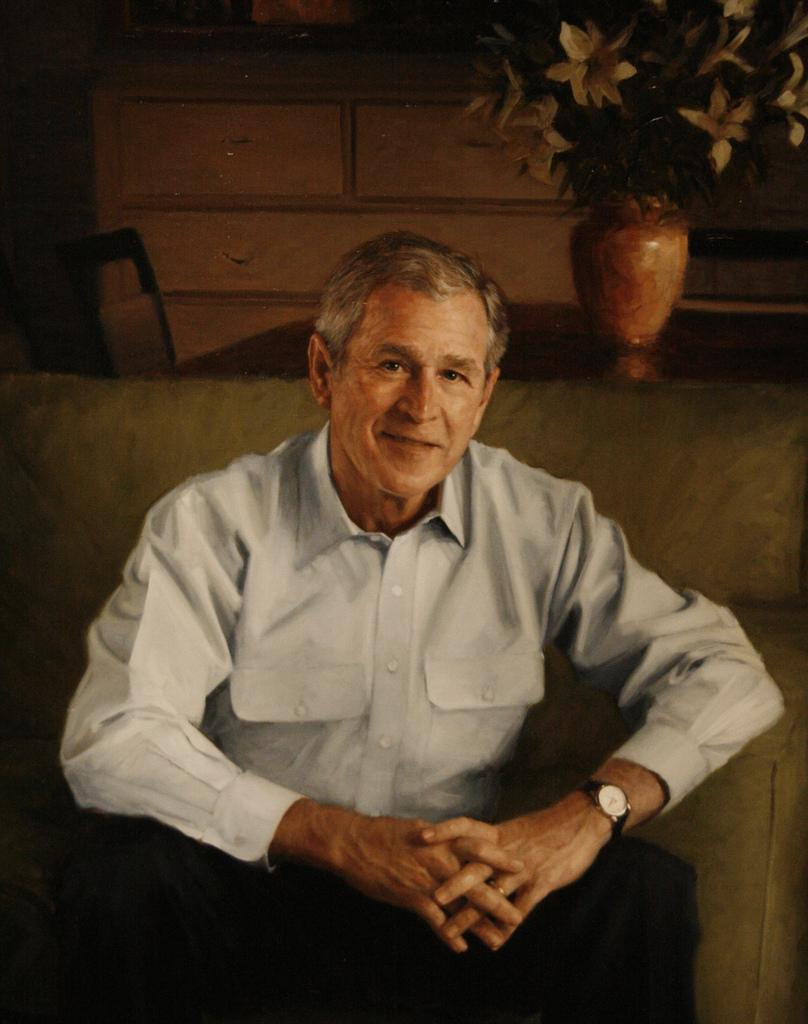What is the main subject of the image? There is a person sitting in the image. Can you describe the background of the image? There is a flower pot in the background of the image. What type of poison is the person holding in the image? There is no poison present in the image; it features a person sitting and a flower pot in the background. 